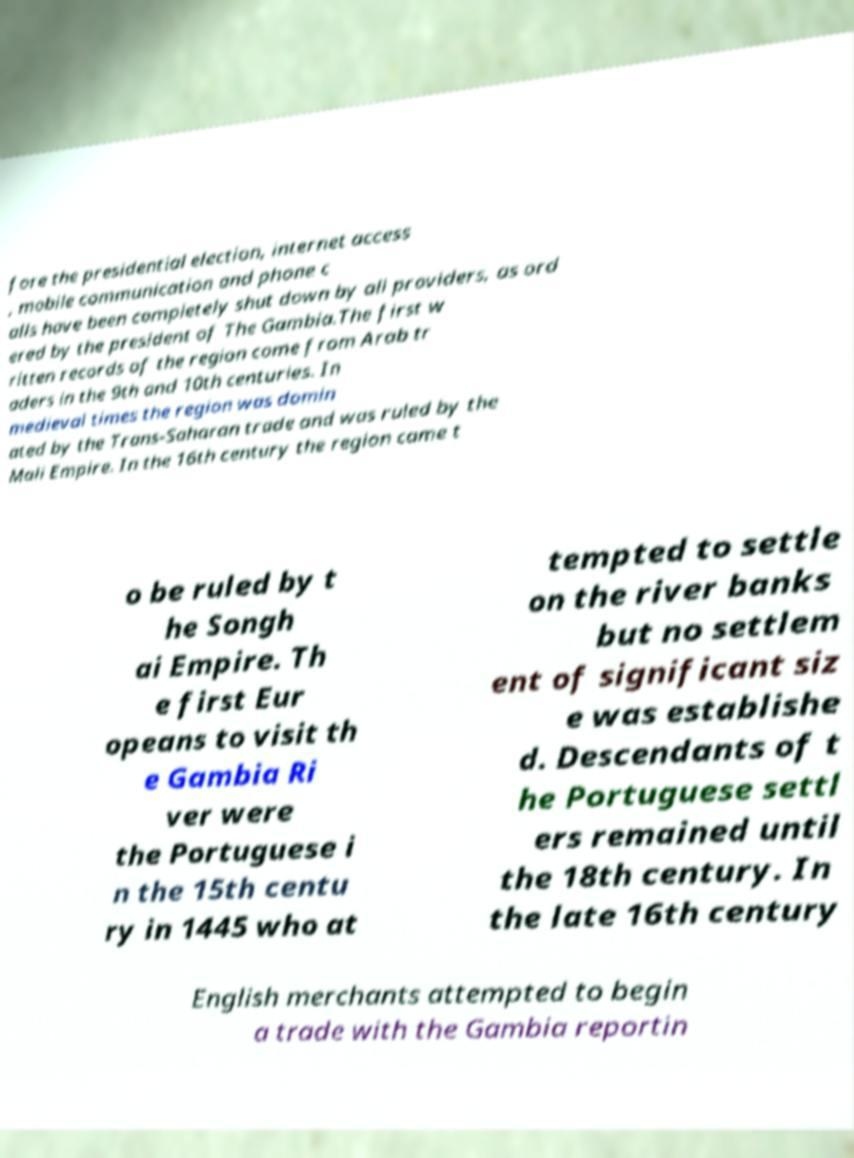Please identify and transcribe the text found in this image. fore the presidential election, internet access , mobile communication and phone c alls have been completely shut down by all providers, as ord ered by the president of The Gambia.The first w ritten records of the region come from Arab tr aders in the 9th and 10th centuries. In medieval times the region was domin ated by the Trans-Saharan trade and was ruled by the Mali Empire. In the 16th century the region came t o be ruled by t he Songh ai Empire. Th e first Eur opeans to visit th e Gambia Ri ver were the Portuguese i n the 15th centu ry in 1445 who at tempted to settle on the river banks but no settlem ent of significant siz e was establishe d. Descendants of t he Portuguese settl ers remained until the 18th century. In the late 16th century English merchants attempted to begin a trade with the Gambia reportin 